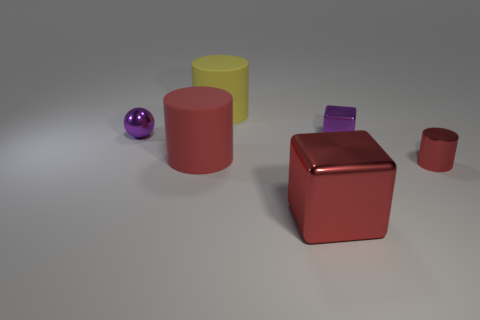Subtract all red cylinders. How many were subtracted if there are1red cylinders left? 1 Add 1 red metallic objects. How many objects exist? 7 Subtract all balls. How many objects are left? 5 Add 3 yellow rubber things. How many yellow rubber things exist? 4 Subtract 0 cyan blocks. How many objects are left? 6 Subtract all small cylinders. Subtract all yellow matte objects. How many objects are left? 4 Add 2 tiny cubes. How many tiny cubes are left? 3 